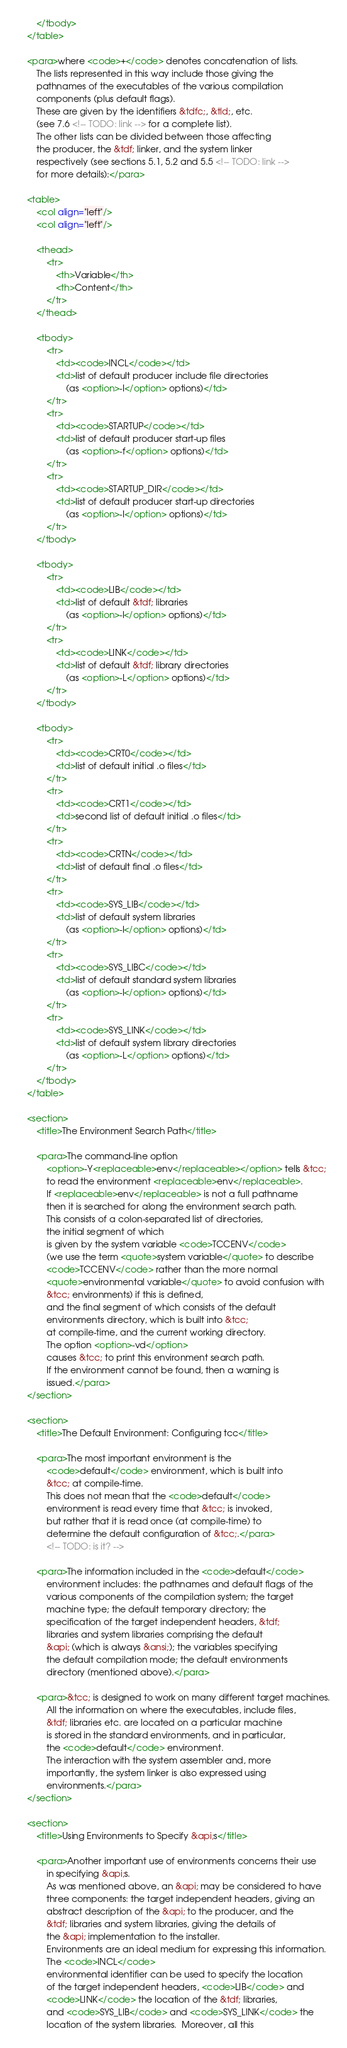Convert code to text. <code><loc_0><loc_0><loc_500><loc_500><_XML_>		</tbody>
	</table>

	<para>where <code>+</code> denotes concatenation of lists.
		The lists represented in this way include those giving the
		pathnames of the executables of the various compilation
		components (plus default flags).
		These are given by the identifiers &tdfc;, &tld;, etc.
		(see 7.6 <!-- TODO: link --> for a complete list).
		The other lists can be divided between those affecting
		the producer, the &tdf; linker, and the system linker
		respectively (see sections 5.1, 5.2 and 5.5 <!-- TODO: link -->
		for more details):</para>

	<table>
		<col align="left"/>
		<col align="left"/>

		<thead>
			<tr>
				<th>Variable</th>
				<th>Content</th>
			</tr>
		</thead>

		<tbody>
			<tr>
				<td><code>INCL</code></td>
				<td>list of default producer include file directories
					(as <option>-I</option> options)</td>
			</tr>
			<tr>
				<td><code>STARTUP</code></td>
				<td>list of default producer start-up files
					(as <option>-f</option> options)</td>
			</tr>
			<tr>
				<td><code>STARTUP_DIR</code></td>
				<td>list of default producer start-up directories
					(as <option>-I</option> options)</td>
			</tr>
		</tbody>

		<tbody>
			<tr>
				<td><code>LIB</code></td>
				<td>list of default &tdf; libraries
					(as <option>-l</option> options)</td>
			</tr>
			<tr>
				<td><code>LINK</code></td>
				<td>list of default &tdf; library directories
					(as <option>-L</option> options)</td>
			</tr>
		</tbody>

		<tbody>
			<tr>
				<td><code>CRT0</code></td>
				<td>list of default initial .o files</td>
			</tr>
			<tr>
				<td><code>CRT1</code></td>
				<td>second list of default initial .o files</td>
			</tr>
			<tr>
				<td><code>CRTN</code></td>
				<td>list of default final .o files</td>
			</tr>
			<tr>
				<td><code>SYS_LIB</code></td>
				<td>list of default system libraries
					(as <option>-l</option> options)</td>
			</tr>
			<tr>
				<td><code>SYS_LIBC</code></td>
				<td>list of default standard system libraries
					(as <option>-l</option> options)</td>
			</tr>
			<tr>
				<td><code>SYS_LINK</code></td>
				<td>list of default system library directories
					(as <option>-L</option> options)</td>
			</tr>
		</tbody>
	</table>

	<section>
		<title>The Environment Search Path</title>

		<para>The command-line option
			<option>-Y<replaceable>env</replaceable></option> tells &tcc;
			to read the environment <replaceable>env</replaceable>.
			If <replaceable>env</replaceable> is not a full pathname
			then it is searched for along the environment search path.
			This consists of a colon-separated list of directories,
			the initial segment of which
			is given by the system variable <code>TCCENV</code>
			(we use the term <quote>system variable</quote> to describe
			<code>TCCENV</code> rather than the more normal
			<quote>environmental variable</quote> to avoid confusion with
			&tcc; environments) if this is defined,
			and the final segment of which consists of the default
			environments directory, which is built into &tcc;
			at compile-time, and the current working directory.
			The option <option>-vd</option>
			causes &tcc; to print this environment search path.
			If the environment cannot be found, then a warning is
			issued.</para>
	</section>

	<section>
		<title>The Default Environment: Configuring tcc</title>

		<para>The most important environment is the
			<code>default</code> environment, which is built into
			&tcc; at compile-time.
			This does not mean that the <code>default</code>
			environment is read every time that &tcc; is invoked,
			but rather that it is read once (at compile-time) to
			determine the default configuration of &tcc;.</para>
			<!-- TODO: is it? -->

		<para>The information included in the <code>default</code>
			environment includes: the pathnames and default flags of the
			various components of the compilation system; the target
			machine type; the default temporary directory; the
			specification of the target independent headers, &tdf;
			libraries and system libraries comprising the default
			&api; (which is always &ansi;); the variables specifying
			the default compilation mode; the default environments
			directory (mentioned above).</para>

		<para>&tcc; is designed to work on many different target machines.
			All the information on where the executables, include files,
			&tdf; libraries etc. are located on a particular machine
			is stored in the standard environments, and in particular,
			the <code>default</code> environment.
			The interaction with the system assembler and, more
			importantly, the system linker is also expressed using
			environments.</para>
	</section>

	<section>
		<title>Using Environments to Specify &api;s</title>

		<para>Another important use of environments concerns their use
			in specifying &api;s.
			As was mentioned above, an &api; may be considered to have
			three components: the target independent headers, giving an
			abstract description of the &api; to the producer, and the
			&tdf; libraries and system libraries, giving the details of
			the &api; implementation to the installer.
			Environments are an ideal medium for expressing this information.
			The <code>INCL</code>
			environmental identifier can be used to specify the location
			of the target independent headers, <code>LIB</code> and
			<code>LINK</code> the location of the &tdf; libraries,
			and <code>SYS_LIB</code> and <code>SYS_LINK</code> the
			location of the system libraries.  Moreover, all this</code> 